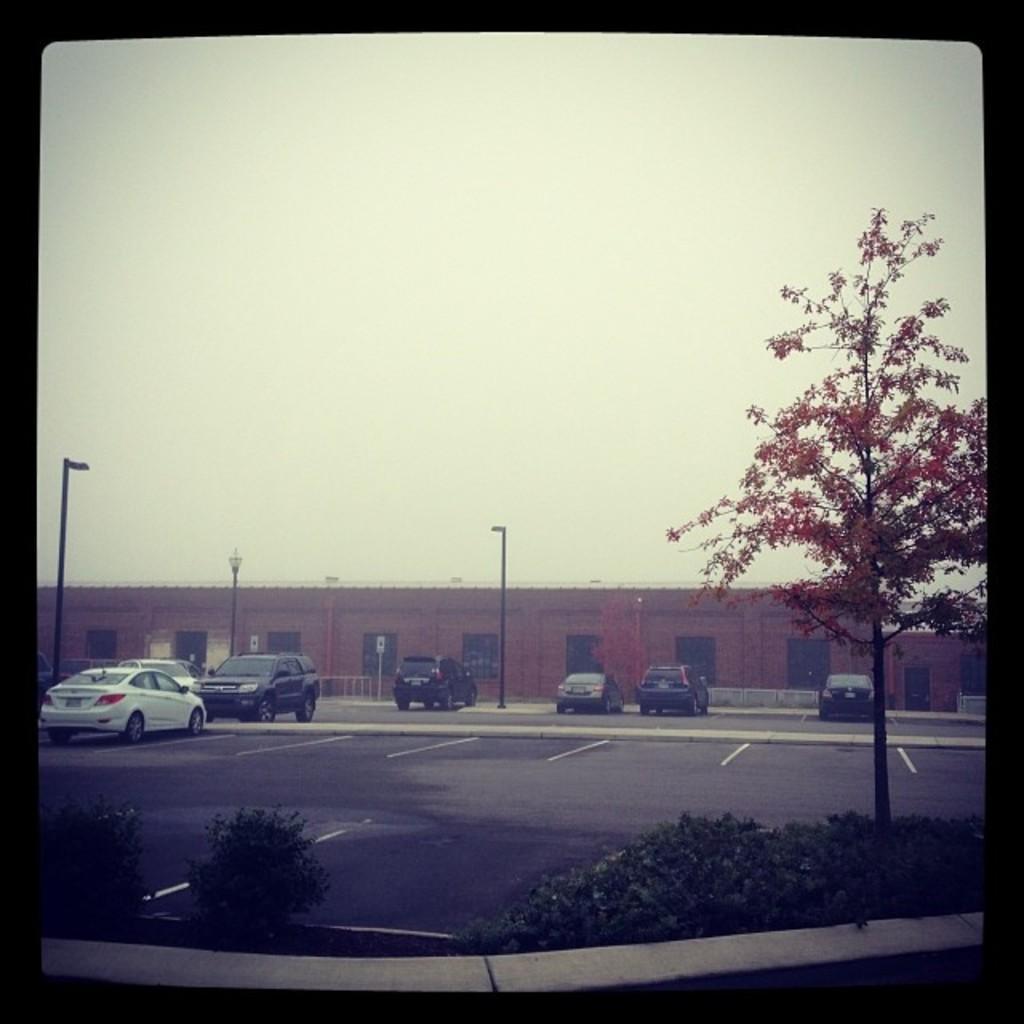Can you describe this image briefly? In this image, we can see the ground with some plants and a tree. There are a few vehicles and poles with lights. We can see a building. We can see the sky. We can see some boards and an object on the right. 